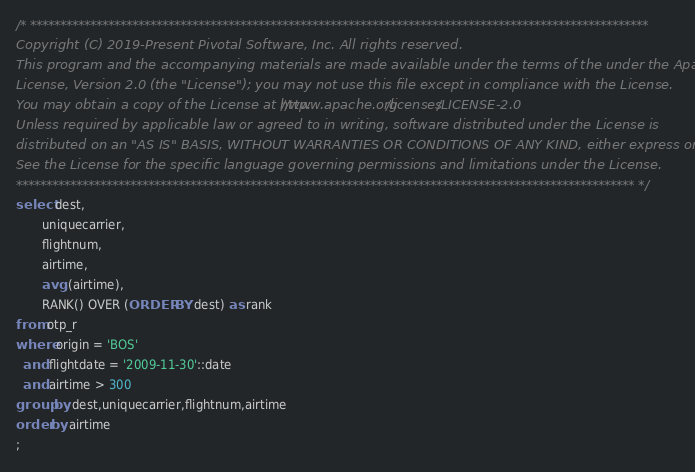Convert code to text. <code><loc_0><loc_0><loc_500><loc_500><_SQL_>/* *******************************************************************************************************
Copyright (C) 2019-Present Pivotal Software, Inc. All rights reserved.
This program and the accompanying materials are made available under the terms of the under the Apache
License, Version 2.0 (the "License"); you may not use this file except in compliance with the License.
You may obtain a copy of the License at http://www.apache.org/licenses/LICENSE-2.0
Unless required by applicable law or agreed to in writing, software distributed under the License is
distributed on an "AS IS" BASIS, WITHOUT WARRANTIES OR CONDITIONS OF ANY KIND, either express or implied.
See the License for the specific language governing permissions and limitations under the License.
******************************************************************************************************* */
select dest,
       uniquecarrier,
       flightnum,
       airtime,
       avg (airtime),
       RANK() OVER (ORDER BY dest) as rank
from otp_r
where origin = 'BOS'
  and flightdate = '2009-11-30'::date
  and airtime > 300
group by dest,uniquecarrier,flightnum,airtime
order by airtime
;
</code> 